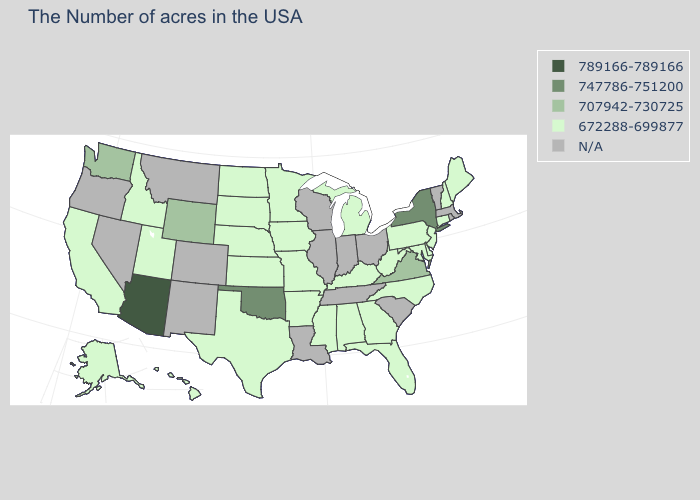What is the value of Arkansas?
Concise answer only. 672288-699877. Does the first symbol in the legend represent the smallest category?
Give a very brief answer. No. Does the map have missing data?
Write a very short answer. Yes. How many symbols are there in the legend?
Be succinct. 5. What is the value of North Carolina?
Be succinct. 672288-699877. Among the states that border Utah , does Idaho have the lowest value?
Concise answer only. Yes. Does New Hampshire have the highest value in the Northeast?
Write a very short answer. No. Among the states that border Oregon , which have the highest value?
Quick response, please. Washington. Among the states that border Massachusetts , which have the highest value?
Write a very short answer. New York. Name the states that have a value in the range N/A?
Quick response, please. Massachusetts, Rhode Island, Vermont, South Carolina, Ohio, Indiana, Tennessee, Wisconsin, Illinois, Louisiana, Colorado, New Mexico, Montana, Nevada, Oregon. What is the value of Arkansas?
Quick response, please. 672288-699877. Is the legend a continuous bar?
Concise answer only. No. Which states have the lowest value in the Northeast?
Concise answer only. Maine, New Hampshire, Connecticut, New Jersey, Pennsylvania. Which states have the highest value in the USA?
Short answer required. Arizona. 